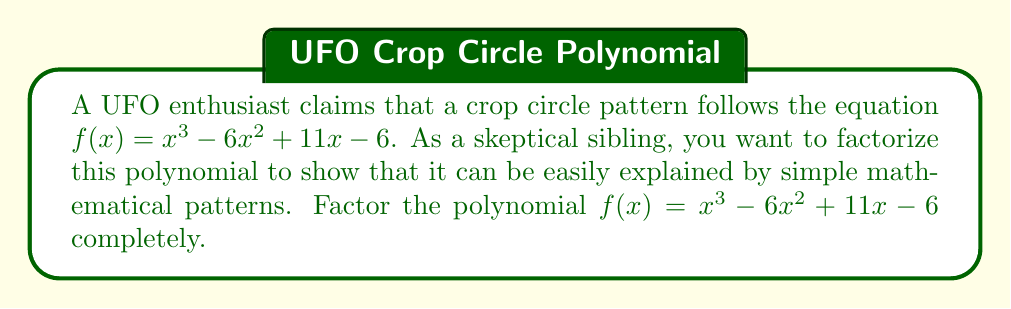Could you help me with this problem? Let's approach this step-by-step:

1) First, we can try to guess one factor. Notice that when $x = 1$, $f(1) = 1^3 - 6(1)^2 + 11(1) - 6 = 1 - 6 + 11 - 6 = 0$. This means $(x-1)$ is a factor.

2) We can use polynomial long division to divide $f(x)$ by $(x-1)$:

   $$\frac{x^3 - 6x^2 + 11x - 6}{x-1} = x^2 - 5x + 6$$

3) So now we have: $f(x) = (x-1)(x^2 - 5x + 6)$

4) We need to factor the quadratic term $x^2 - 5x + 6$. We can do this by finding two numbers that multiply to give 6 and add to give -5. These numbers are -2 and -3.

5) Therefore, $x^2 - 5x + 6 = (x-2)(x-3)$

6) Putting it all together, we get:

   $f(x) = (x-1)(x-2)(x-3)$

This factorization shows that the polynomial is simply the product of three linear terms, which could easily arise from natural or man-made patterns, rather than requiring any extraordinary explanation.
Answer: $f(x) = (x-1)(x-2)(x-3)$ 